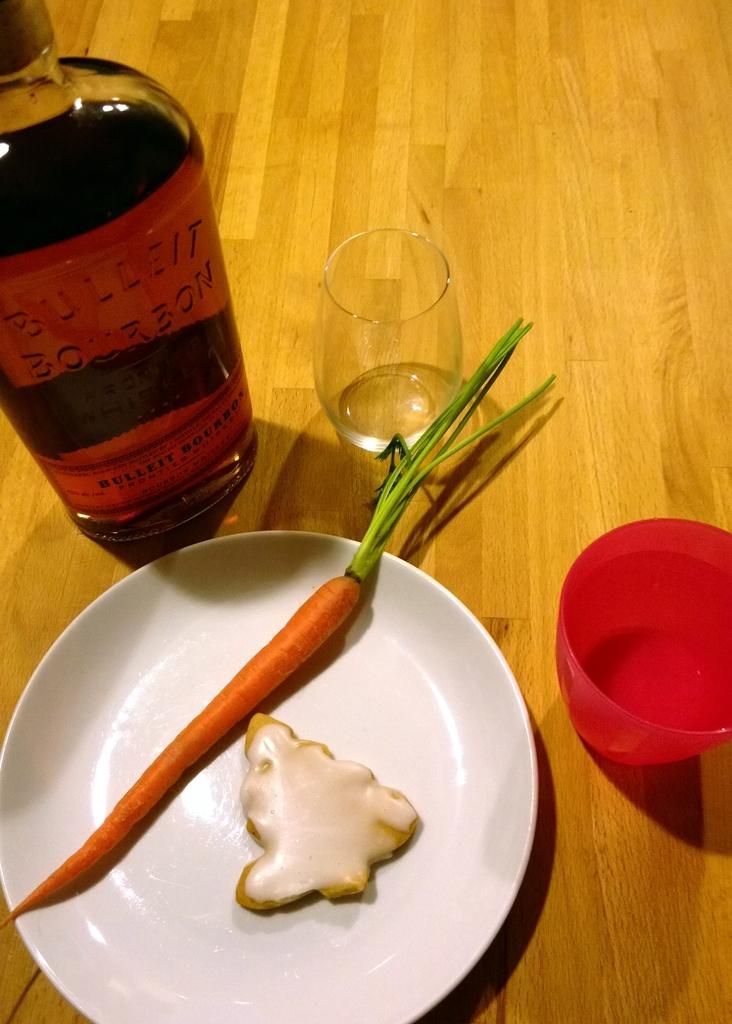What is in the bottle?
Give a very brief answer. Bulleit bourbon. What brand of alcohol is it?
Your response must be concise. Bulleit. 